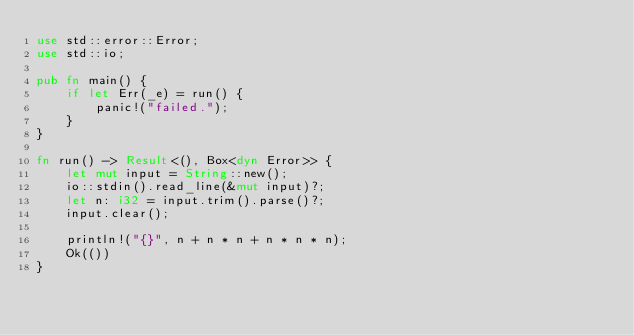<code> <loc_0><loc_0><loc_500><loc_500><_Rust_>use std::error::Error;
use std::io;

pub fn main() {
    if let Err(_e) = run() {
        panic!("failed.");
    }
}

fn run() -> Result<(), Box<dyn Error>> {
    let mut input = String::new();
    io::stdin().read_line(&mut input)?;
    let n: i32 = input.trim().parse()?;
    input.clear();

    println!("{}", n + n * n + n * n * n);
    Ok(())
}
</code> 